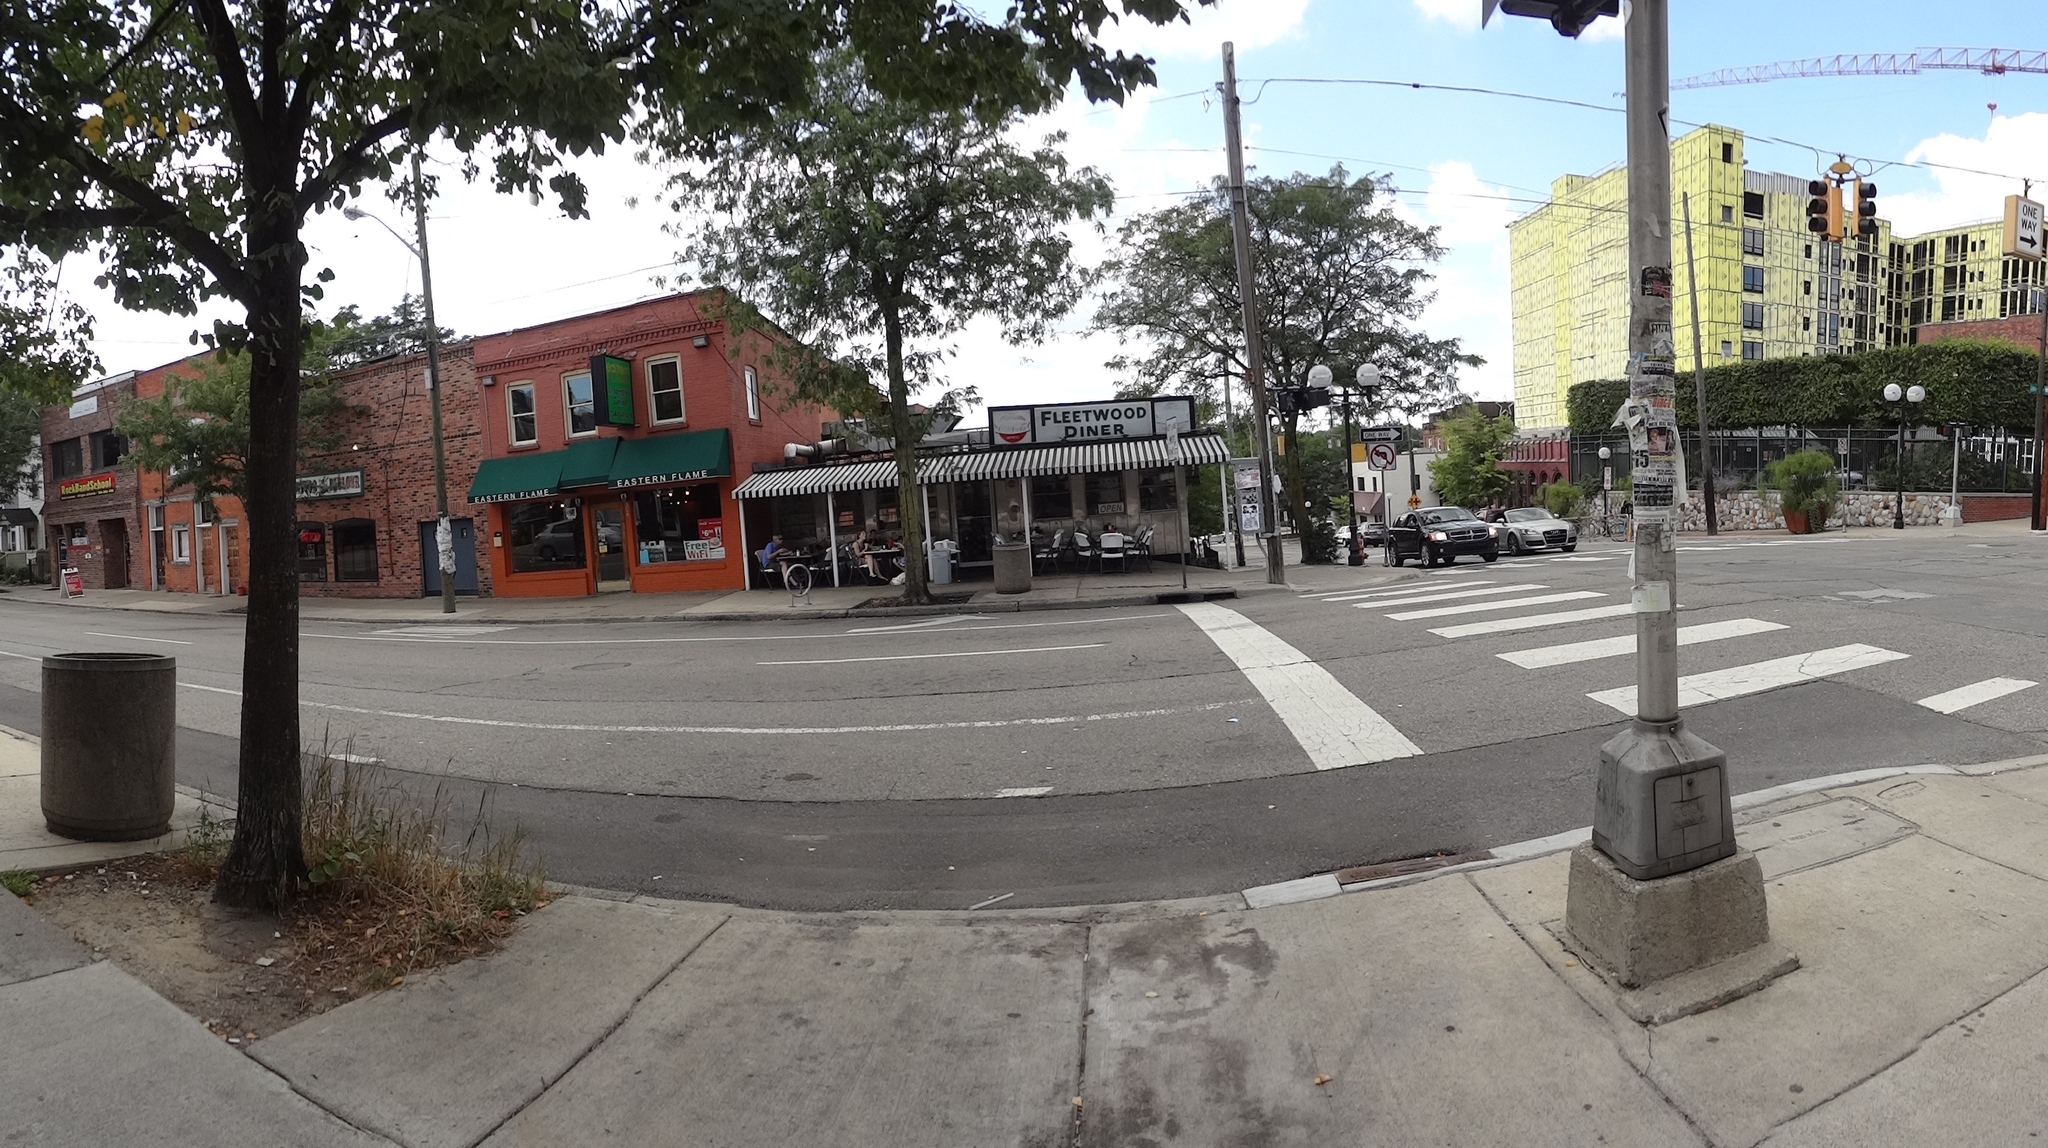Could you give a brief overview of what you see in this image? In this image we can see a few buildings, there are some trees, poles, lights, shops, windows, plants, fence, people, boards and vehicles on the road, in the background we can see the sky with clouds. 